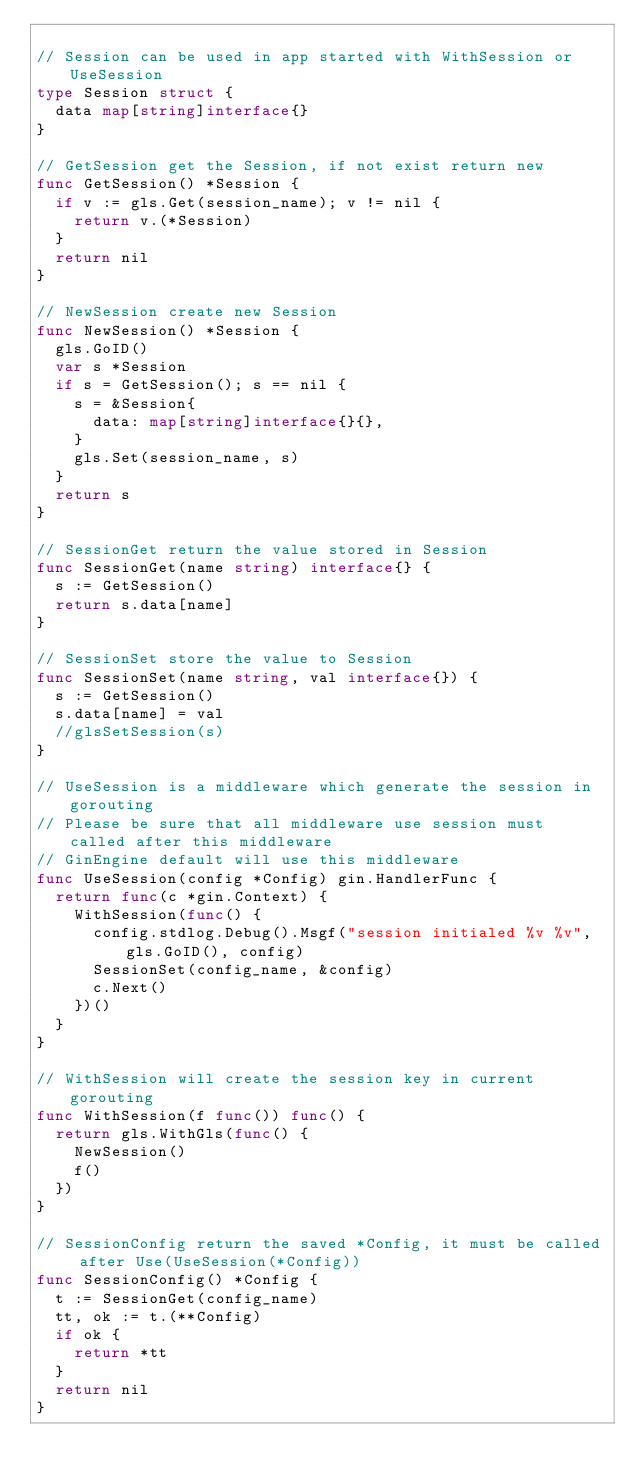Convert code to text. <code><loc_0><loc_0><loc_500><loc_500><_Go_>
// Session can be used in app started with WithSession or UseSession
type Session struct {
	data map[string]interface{}
}

// GetSession get the Session, if not exist return new
func GetSession() *Session {
	if v := gls.Get(session_name); v != nil {
		return v.(*Session)
	}
	return nil
}

// NewSession create new Session
func NewSession() *Session {
	gls.GoID()
	var s *Session
	if s = GetSession(); s == nil {
		s = &Session{
			data: map[string]interface{}{},
		}
		gls.Set(session_name, s)
	}
	return s
}

// SessionGet return the value stored in Session
func SessionGet(name string) interface{} {
	s := GetSession()
	return s.data[name]
}

// SessionSet store the value to Session
func SessionSet(name string, val interface{}) {
	s := GetSession()
	s.data[name] = val
	//glsSetSession(s)
}

// UseSession is a middleware which generate the session in gorouting
// Please be sure that all middleware use session must called after this middleware
// GinEngine default will use this middleware
func UseSession(config *Config) gin.HandlerFunc {
	return func(c *gin.Context) {
		WithSession(func() {
			config.stdlog.Debug().Msgf("session initialed %v %v", gls.GoID(), config)
			SessionSet(config_name, &config)
			c.Next()
		})()
	}
}

// WithSession will create the session key in current gorouting
func WithSession(f func()) func() {
	return gls.WithGls(func() {
		NewSession()
		f()
	})
}

// SessionConfig return the saved *Config, it must be called after Use(UseSession(*Config))
func SessionConfig() *Config {
	t := SessionGet(config_name)
	tt, ok := t.(**Config)
	if ok {
		return *tt
	}
	return nil
}
</code> 